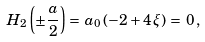Convert formula to latex. <formula><loc_0><loc_0><loc_500><loc_500>H _ { 2 } \left ( \pm \frac { a } { 2 } \right ) = \, a _ { 0 } \left ( - 2 + 4 \, \xi \right ) \, = \, 0 \, ,</formula> 